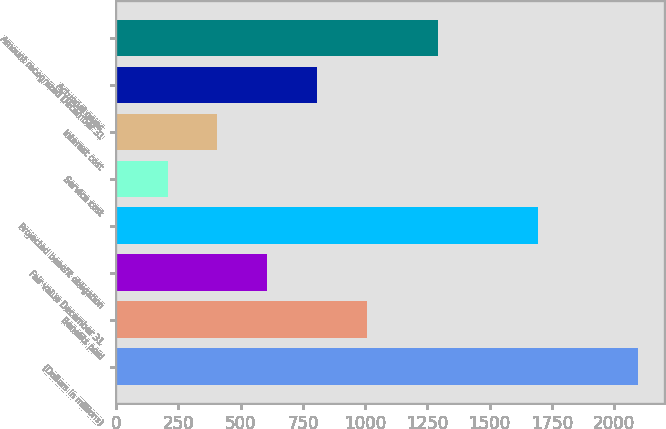<chart> <loc_0><loc_0><loc_500><loc_500><bar_chart><fcel>(Dollars in millions)<fcel>Benefits paid<fcel>Fair value December 31<fcel>Projected benefit obligation<fcel>Service cost<fcel>Interest cost<fcel>Actuarial gains<fcel>Amount recognized December 31<nl><fcel>2094.8<fcel>1007<fcel>606.6<fcel>1694.4<fcel>206.2<fcel>406.4<fcel>806.8<fcel>1294<nl></chart> 